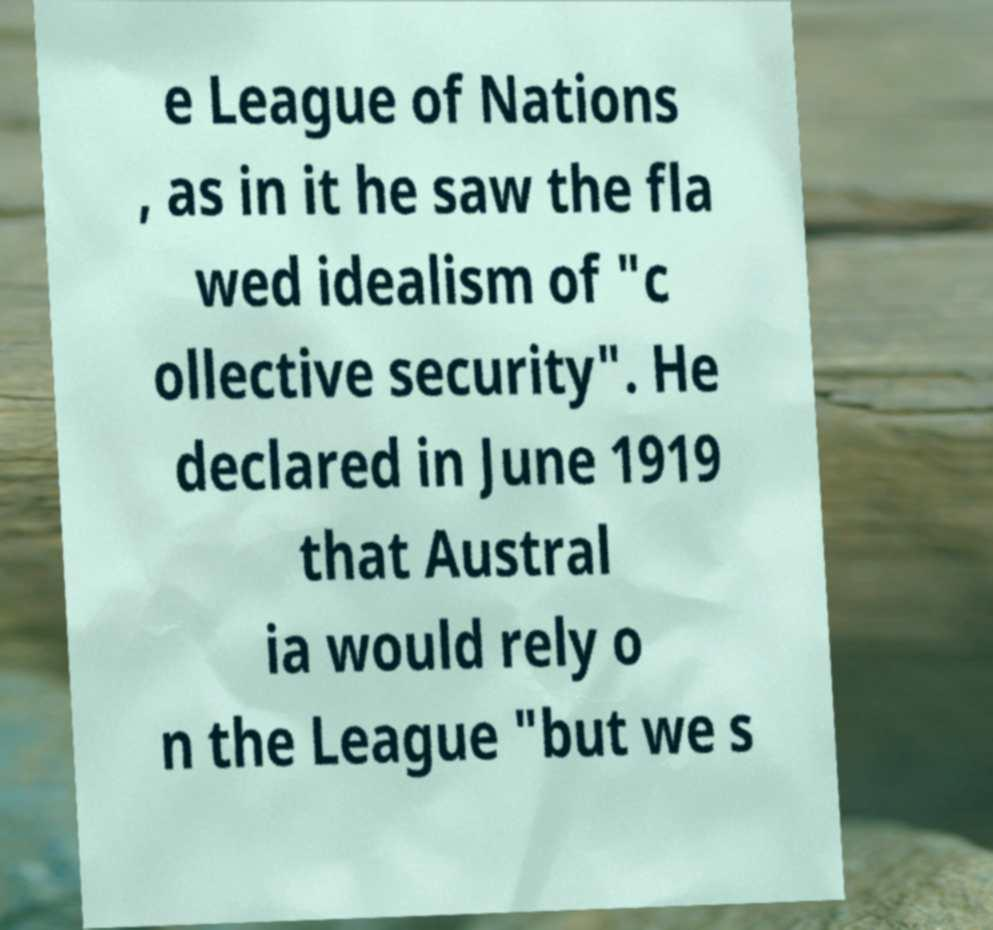Please read and relay the text visible in this image. What does it say? e League of Nations , as in it he saw the fla wed idealism of "c ollective security". He declared in June 1919 that Austral ia would rely o n the League "but we s 